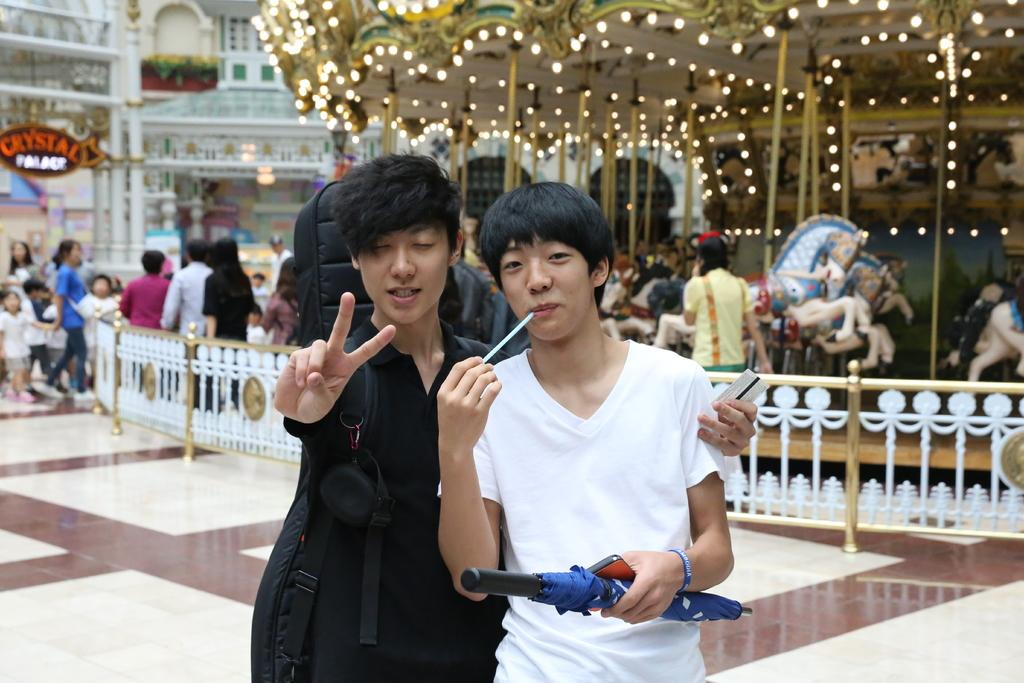How many people are in the image? There is a group of people in the image, but the exact number cannot be determined from the provided facts. What can be seen illuminated in the image? There are lights in the image, which may be used to illuminate the scene. What type of structures are visible in the image? There are buildings in the image, which suggests an urban or city setting. What is written or displayed on the banner in the image? The content of the banner cannot be determined from the provided facts. What type of barrier is present in the image? There is a fence in the image, which may serve as a boundary or enclosure. What type of statue is present in the image? There is a horse statue in the image, which may be a decorative or commemorative feature. How does the distribution of hammers affect the taste of the food in the image? There is no mention of hammers or food in the image, so this question cannot be answered based on the provided facts. 